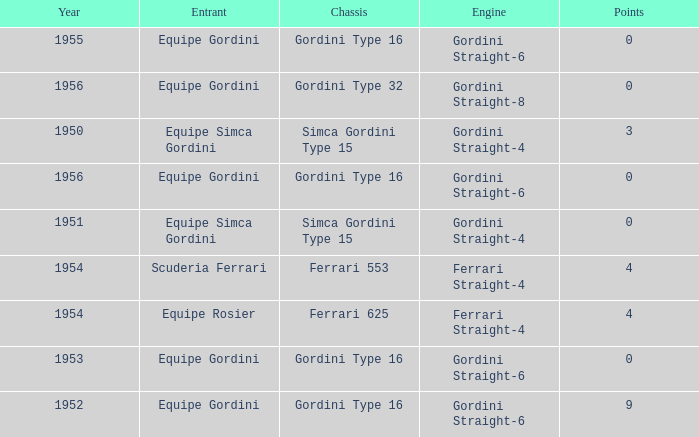What engine was used by Equipe Simca Gordini before 1956 with less than 4 points? Gordini Straight-4, Gordini Straight-4. 